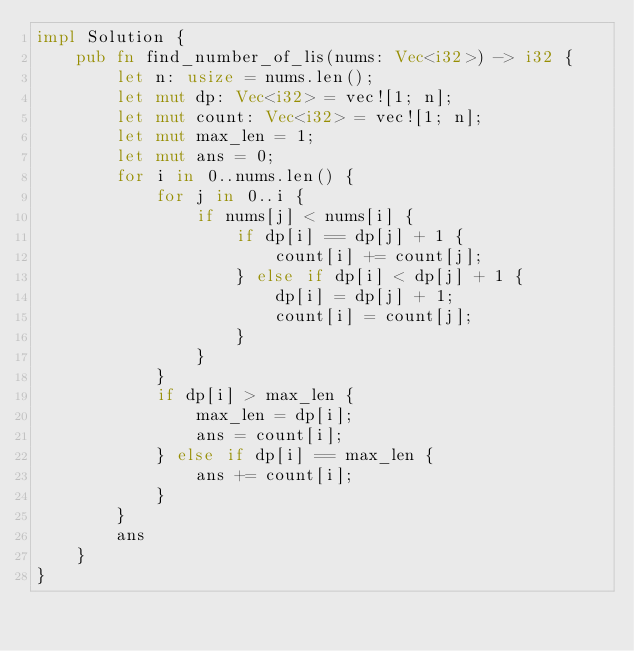<code> <loc_0><loc_0><loc_500><loc_500><_Rust_>impl Solution {
    pub fn find_number_of_lis(nums: Vec<i32>) -> i32 {
        let n: usize = nums.len();
        let mut dp: Vec<i32> = vec![1; n];
        let mut count: Vec<i32> = vec![1; n];
        let mut max_len = 1;
        let mut ans = 0;
        for i in 0..nums.len() {
            for j in 0..i {
                if nums[j] < nums[i] {
                    if dp[i] == dp[j] + 1 {
                        count[i] += count[j];
                    } else if dp[i] < dp[j] + 1 {
                        dp[i] = dp[j] + 1;
                        count[i] = count[j];
                    }
                }
            }
            if dp[i] > max_len {
                max_len = dp[i];
                ans = count[i];
            } else if dp[i] == max_len {
                ans += count[i];
            }
        }
        ans
    }
}</code> 